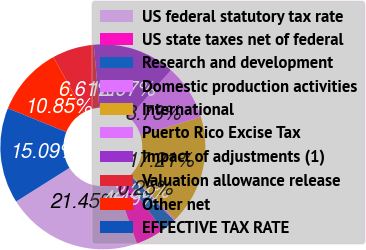Convert chart to OTSL. <chart><loc_0><loc_0><loc_500><loc_500><pie_chart><fcel>US federal statutory tax rate<fcel>US state taxes net of federal<fcel>Research and development<fcel>Domestic production activities<fcel>International<fcel>Puerto Rico Excise Tax<fcel>Impact of adjustments (1)<fcel>Valuation allowance release<fcel>Other net<fcel>EFFECTIVE TAX RATE<nl><fcel>21.45%<fcel>4.49%<fcel>2.37%<fcel>0.25%<fcel>17.21%<fcel>8.73%<fcel>12.97%<fcel>6.61%<fcel>10.85%<fcel>15.09%<nl></chart> 